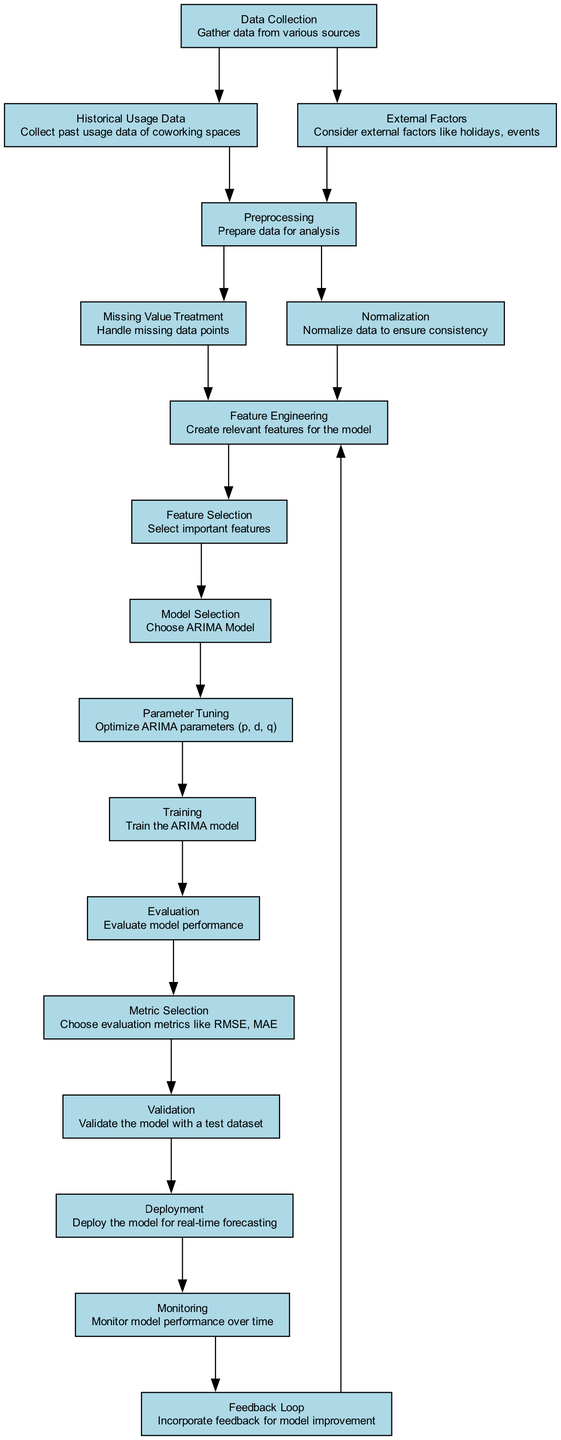What is the starting point of the diagram? The starting point is the "Data Collection" node, which represents the initial step in the demand forecasting process for co-working spaces.
Answer: Data Collection How many nodes are present in the diagram? By counting all the unique nodes listed in the diagram, we find there are a total of 16 nodes.
Answer: 16 Which node comes directly after "Model Selection"? Following "Model Selection" in the diagram is the "Parameter Tuning" node, indicating the next step in the process after selecting the model.
Answer: Parameter Tuning What is involved in the "Preprocessing" stage? The "Preprocessing" stage includes handling missing values through "Missing Value Treatment" and normalizing data through "Normalization," combining both processes to prepare data for analysis.
Answer: Missing Value Treatment and Normalization How does the "Feedback Loop" contribute to the process? The "Feedback Loop" connects to "Feature Engineering," indicating that the insights gained from monitoring the model's performance directly influence future adjustments and improvements in feature engineering.
Answer: Incorporate feedback for model improvement What evaluation metrics are chosen after "Evaluation"? After the "Evaluation" stage, the diagram specifies that metrics such as RMSE and MAE are selected under "Metric Selection" to assess model performance quantitatively.
Answer: RMSE, MAE What is the relationship between "Validation" and "Deployment"? The "Validation" node leads to the "Deployment" node, meaning that validating the model is a necessary step before the model can be deployed for real-time forecasting.
Answer: Validation leads to Deployment In which stage is the model trained? The training of the model occurs at the "Training" stage, which follows the "Parameter Tuning" process, where the optimized parameters are applied to the model.
Answer: Training What type of data is collected in the "Historical Usage Data" node? The "Historical Usage Data" node specifically refers to the past usage data collected from co-working spaces, which is critical for forecasting future demand.
Answer: Past usage data of coworking spaces 